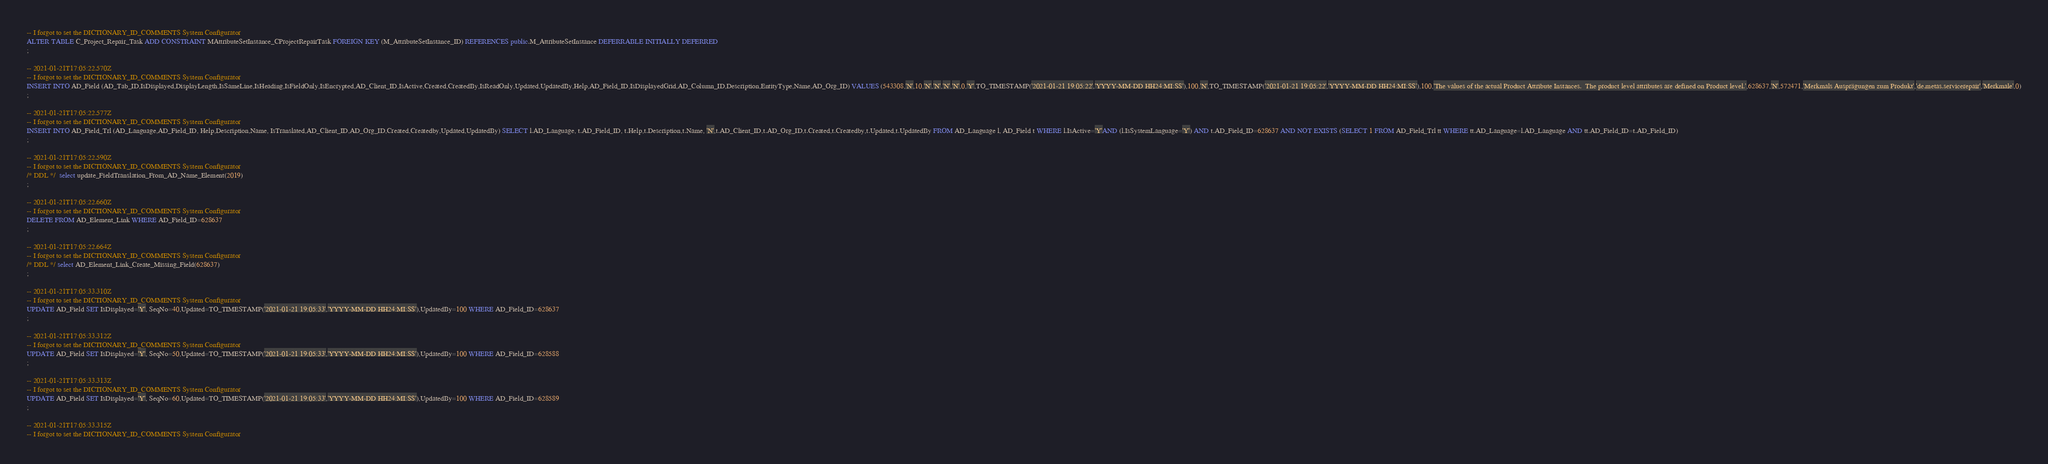<code> <loc_0><loc_0><loc_500><loc_500><_SQL_>-- I forgot to set the DICTIONARY_ID_COMMENTS System Configurator
ALTER TABLE C_Project_Repair_Task ADD CONSTRAINT MAttributeSetInstance_CProjectRepairTask FOREIGN KEY (M_AttributeSetInstance_ID) REFERENCES public.M_AttributeSetInstance DEFERRABLE INITIALLY DEFERRED
;

-- 2021-01-21T17:05:22.570Z
-- I forgot to set the DICTIONARY_ID_COMMENTS System Configurator
INSERT INTO AD_Field (AD_Tab_ID,IsDisplayed,DisplayLength,IsSameLine,IsHeading,IsFieldOnly,IsEncrypted,AD_Client_ID,IsActive,Created,CreatedBy,IsReadOnly,Updated,UpdatedBy,Help,AD_Field_ID,IsDisplayedGrid,AD_Column_ID,Description,EntityType,Name,AD_Org_ID) VALUES (543308,'N',10,'N','N','N','N',0,'Y',TO_TIMESTAMP('2021-01-21 19:05:22','YYYY-MM-DD HH24:MI:SS'),100,'N',TO_TIMESTAMP('2021-01-21 19:05:22','YYYY-MM-DD HH24:MI:SS'),100,'The values of the actual Product Attribute Instances.  The product level attributes are defined on Product level.',628637,'N',572471,'Merkmals Ausprägungen zum Produkt','de.metas.servicerepair','Merkmale',0)
;

-- 2021-01-21T17:05:22.577Z
-- I forgot to set the DICTIONARY_ID_COMMENTS System Configurator
INSERT INTO AD_Field_Trl (AD_Language,AD_Field_ID, Help,Description,Name, IsTranslated,AD_Client_ID,AD_Org_ID,Created,Createdby,Updated,UpdatedBy) SELECT l.AD_Language, t.AD_Field_ID, t.Help,t.Description,t.Name, 'N',t.AD_Client_ID,t.AD_Org_ID,t.Created,t.Createdby,t.Updated,t.UpdatedBy FROM AD_Language l, AD_Field t WHERE l.IsActive='Y'AND (l.IsSystemLanguage='Y') AND t.AD_Field_ID=628637 AND NOT EXISTS (SELECT 1 FROM AD_Field_Trl tt WHERE tt.AD_Language=l.AD_Language AND tt.AD_Field_ID=t.AD_Field_ID)
;

-- 2021-01-21T17:05:22.590Z
-- I forgot to set the DICTIONARY_ID_COMMENTS System Configurator
/* DDL */  select update_FieldTranslation_From_AD_Name_Element(2019) 
;

-- 2021-01-21T17:05:22.660Z
-- I forgot to set the DICTIONARY_ID_COMMENTS System Configurator
DELETE FROM AD_Element_Link WHERE AD_Field_ID=628637
;

-- 2021-01-21T17:05:22.664Z
-- I forgot to set the DICTIONARY_ID_COMMENTS System Configurator
/* DDL */ select AD_Element_Link_Create_Missing_Field(628637)
;

-- 2021-01-21T17:05:33.310Z
-- I forgot to set the DICTIONARY_ID_COMMENTS System Configurator
UPDATE AD_Field SET IsDisplayed='Y', SeqNo=40,Updated=TO_TIMESTAMP('2021-01-21 19:05:33','YYYY-MM-DD HH24:MI:SS'),UpdatedBy=100 WHERE AD_Field_ID=628637
;

-- 2021-01-21T17:05:33.312Z
-- I forgot to set the DICTIONARY_ID_COMMENTS System Configurator
UPDATE AD_Field SET IsDisplayed='Y', SeqNo=50,Updated=TO_TIMESTAMP('2021-01-21 19:05:33','YYYY-MM-DD HH24:MI:SS'),UpdatedBy=100 WHERE AD_Field_ID=628588
;

-- 2021-01-21T17:05:33.313Z
-- I forgot to set the DICTIONARY_ID_COMMENTS System Configurator
UPDATE AD_Field SET IsDisplayed='Y', SeqNo=60,Updated=TO_TIMESTAMP('2021-01-21 19:05:33','YYYY-MM-DD HH24:MI:SS'),UpdatedBy=100 WHERE AD_Field_ID=628589
;

-- 2021-01-21T17:05:33.315Z
-- I forgot to set the DICTIONARY_ID_COMMENTS System Configurator</code> 